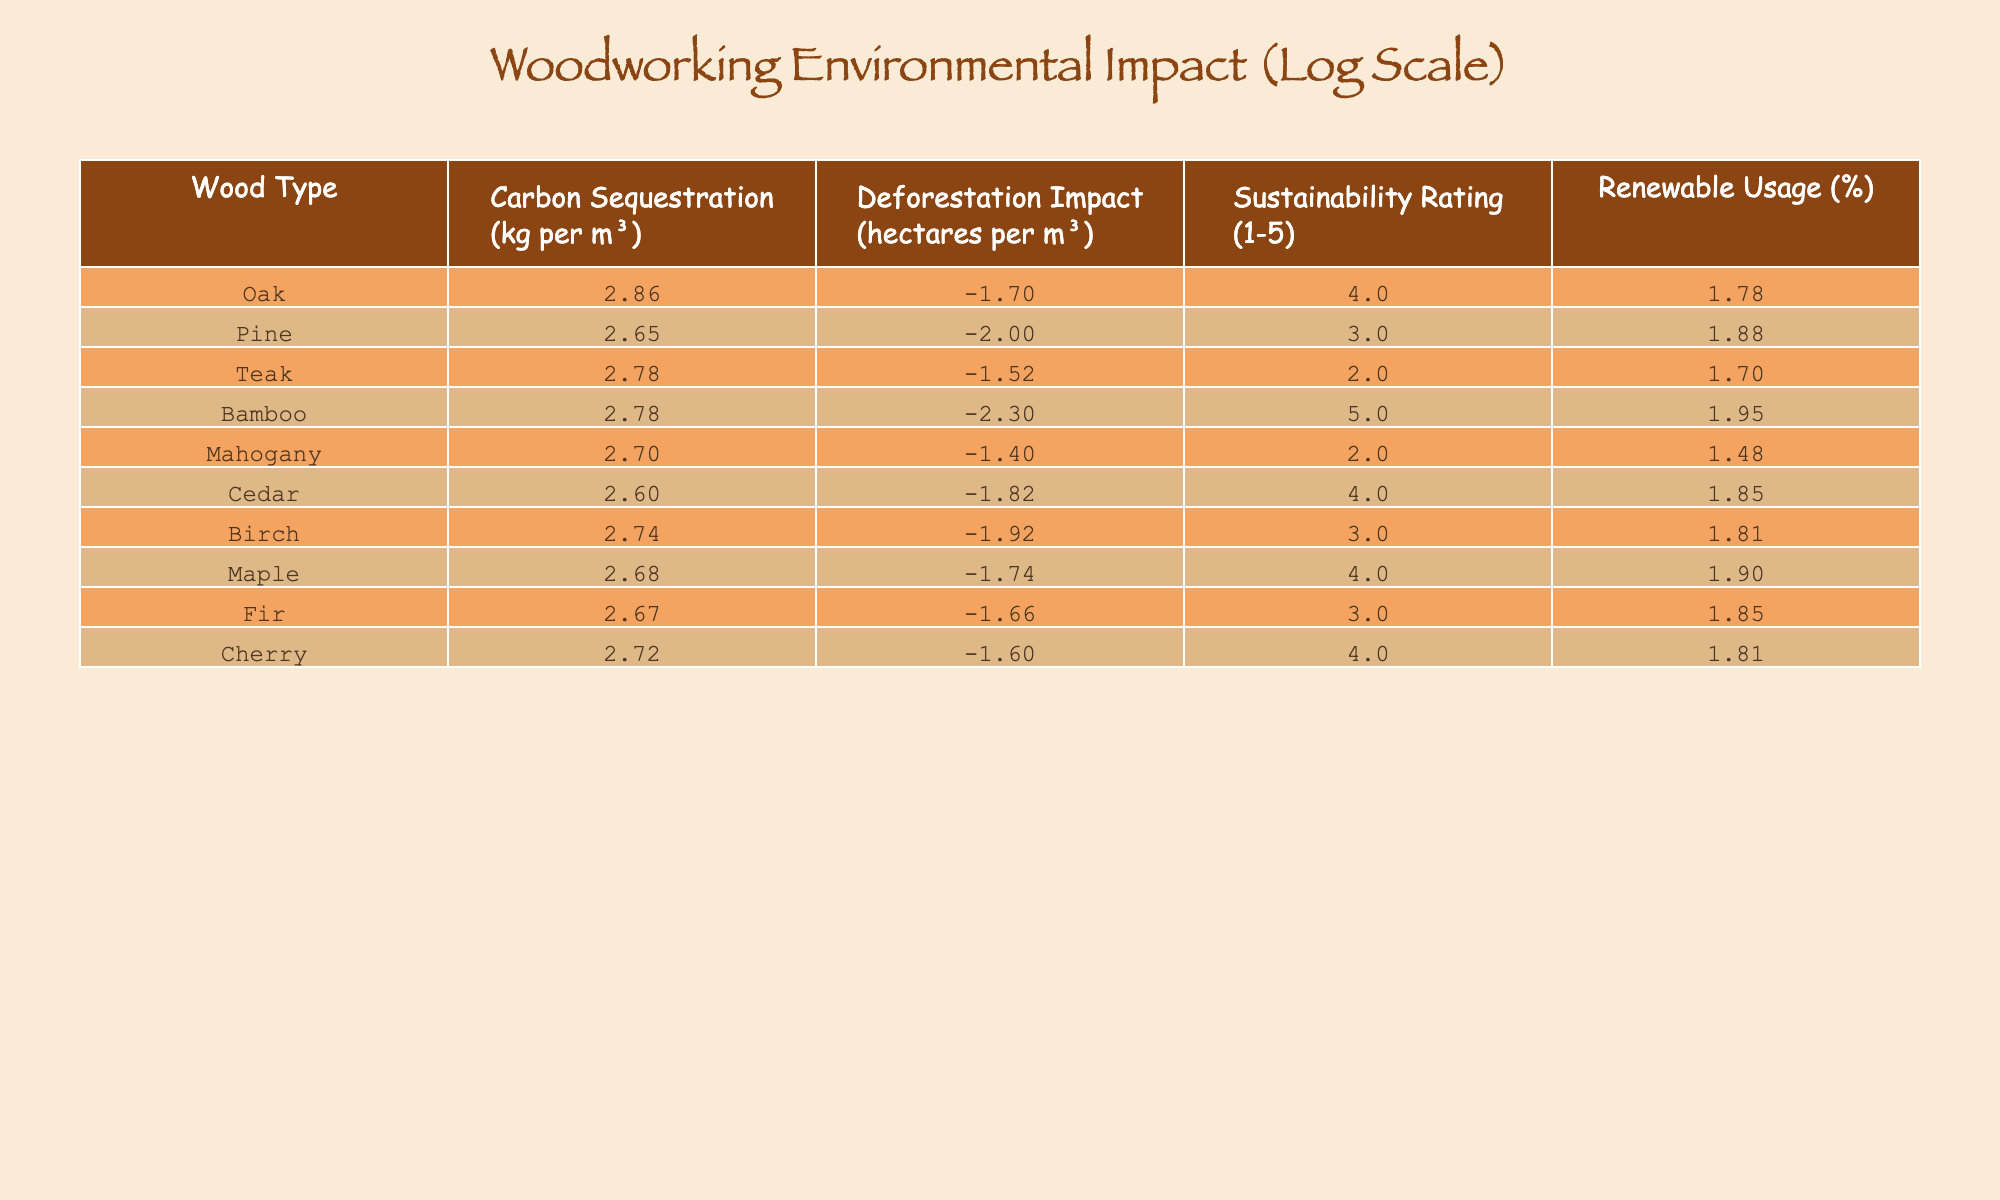What is the sustainability rating of Oak? The sustainability rating column indicates the rating on a scale from 1 to 5. For Oak, the table shows a rating of 4.
Answer: 4 Which wood type has the highest carbon sequestration? By looking at the carbon sequestration column, Oak has the highest value of 730 kg per m³ compared to all other wood types listed.
Answer: Oak What is the deforestation impact of Bamboo? The table lists the deforestation impact for Bamboo as 0.005 hectares per m³, which can be directly found in the corresponding column.
Answer: 0.005 Which wood types have a renewable usage percentage greater than 70%? By checking the renewable usage column, the wood types with percentages greater than 70% are Pine (75%), Bamboo (90%), Maple (80%), and Cedar (70%).
Answer: Pine, Bamboo, Maple, Cedar What is the difference in carbon sequestration between Teak and Mahogany? The carbon sequestration value for Teak is 600 kg per m³, and for Mahogany, it is 500 kg per m³. The difference can be calculated as 600 - 500 = 100 kg per m³.
Answer: 100 kg per m³ Is it true that Cedar has a lower deforestation impact than Pine? The deforestation impact of Cedar is 0.015 hectares per m³ while for Pine it is 0.01 hectares per m³. Since 0.015 is greater than 0.01, it is false that Cedar has a lower impact.
Answer: False What is the average renewable usage percentage of the wood types listed? To calculate the average, sum the renewable usage percentages (60 + 75 + 50 + 90 + 30 + 70 + 65 + 80 + 70 + 65 =  65) and divide by the total number of wood types (10). The average is 65%.
Answer: 65% Which wood type has the lowest sustainability rating? In the sustainability rating column, both Teak and Mahogany have the lowest rating of 2, which can be identified by filtering for the lowest values.
Answer: Teak, Mahogany What is the ratio of carbon sequestration between Bamboo and Fir? For Bamboo, the carbon sequestration is 600 kg per m³, and for Fir, it is 470 kg per m³. The ratio can be calculated as 600 ÷ 470, which approximately equals 1.28 as a decimal ratio.
Answer: 1.28 